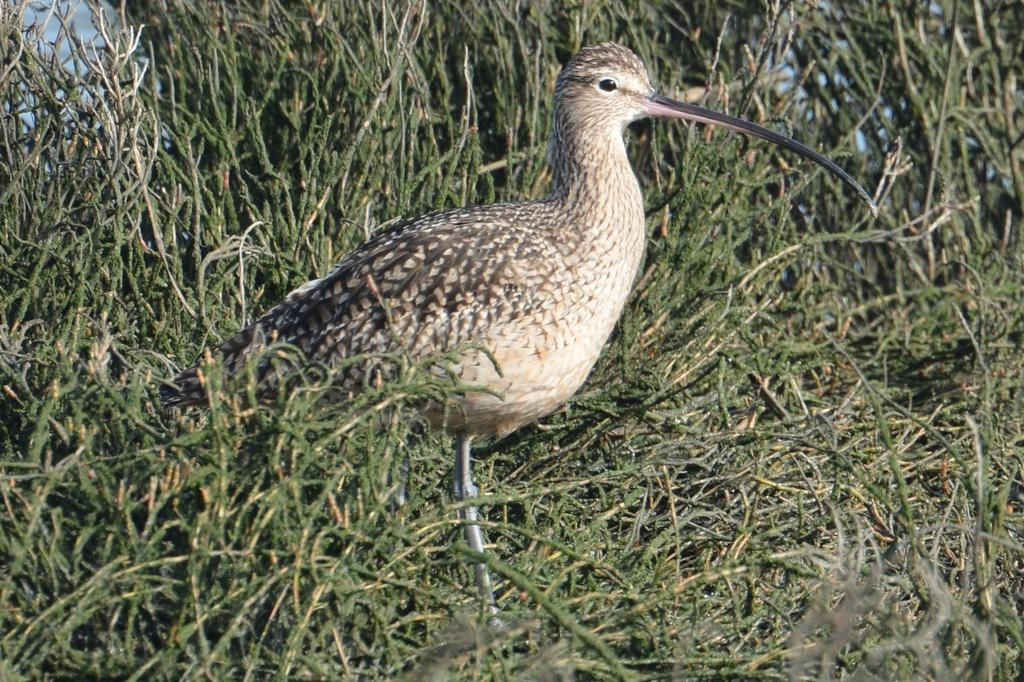What type of animal is in the image? There is a bird in the image. Can you describe the bird's appearance? The bird has brown and black colors. What can be seen in the background of the image? There is green grass in the background of the image. What type of vegetable is the bird holding in the image? There is no vegetable present in the image, and the bird is not holding anything. 